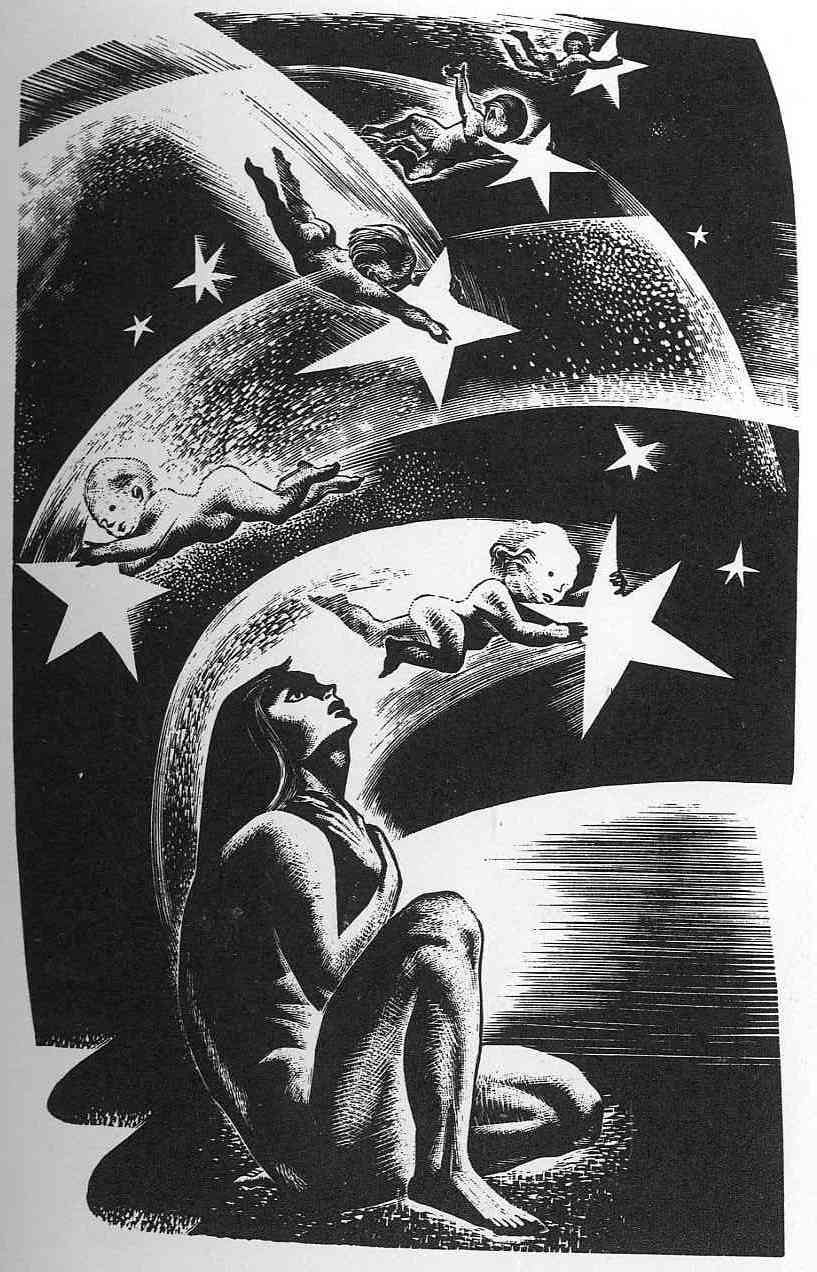What emotions or themes does this image evoke, and how are these conveyed through its visual elements? The image evokes themes of solitude, contemplation, and perhaps a connectedness to the cosmos, conveyed through the solitary figure of the woman and her thoughtful posture. The playfulness of the celestial children further introduces contrast, suggesting themes of innocence and curiosity. The use of stark black and white enhances the mood of mystery and introspection, while the detailed textures and contrasting elements add depth and a sense of movement, inviting viewers into a world beyond the ordinary. 